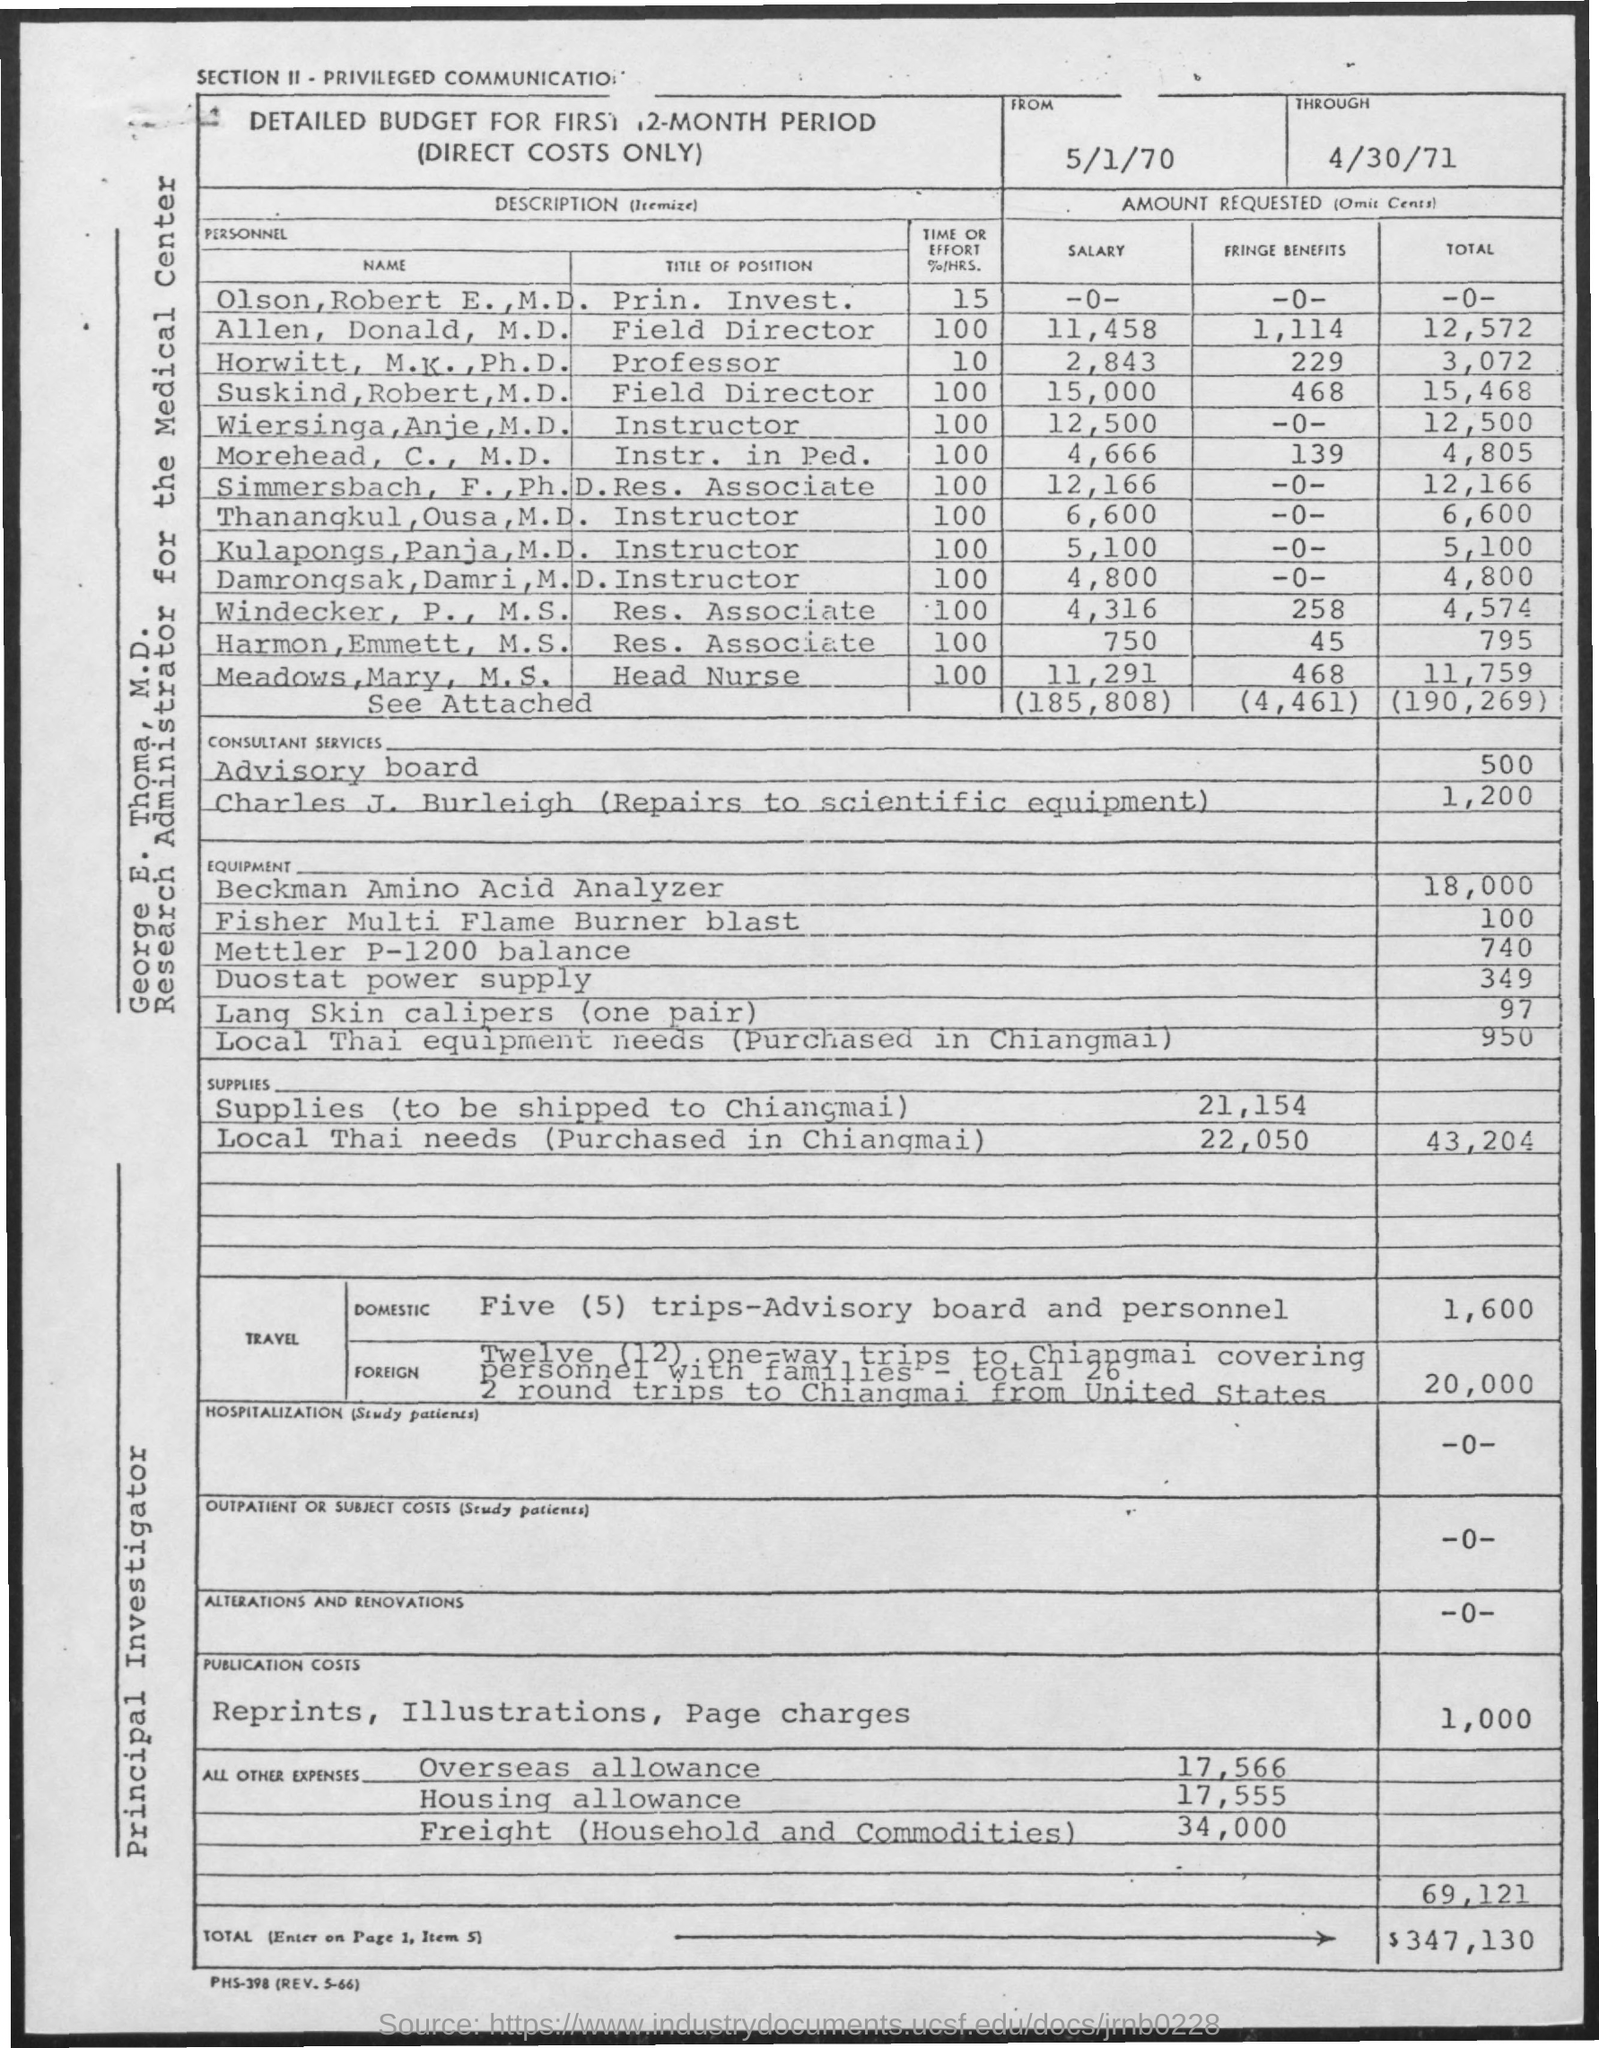What is the designation of George E. Thoma?
Make the answer very short. Research administrator for the medical center. 